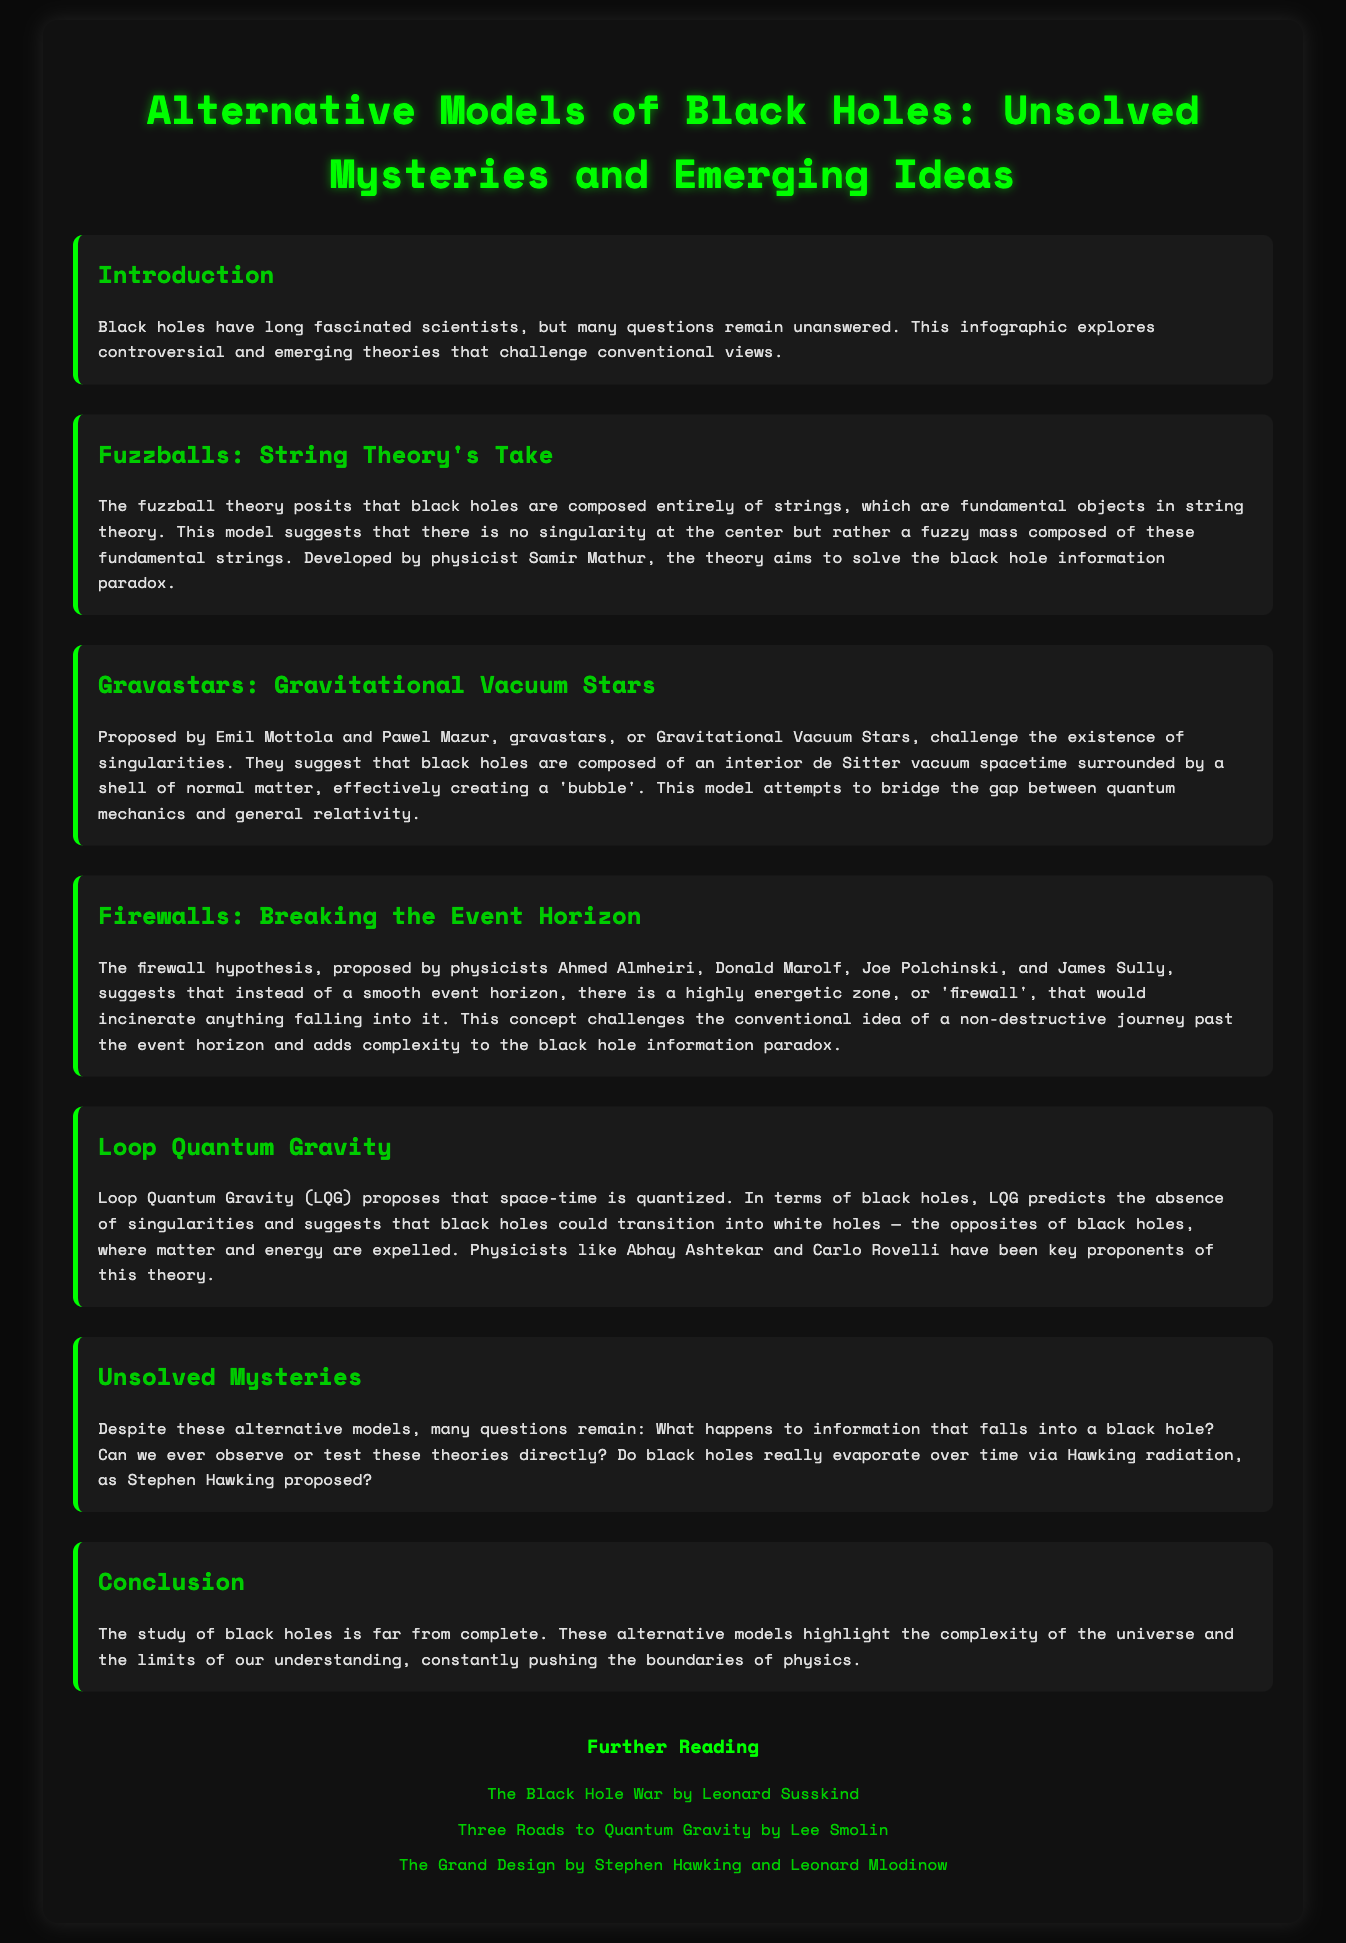What theory suggests black holes are made of strings? The document states that the fuzzball theory posits that black holes are composed entirely of strings.
Answer: Fuzzballs Who developed the fuzzball theory? The document mentions that the fuzzball theory was developed by physicist Samir Mathur.
Answer: Samir Mathur What do gravastars challenge? According to the document, gravastars challenge the existence of singularities.
Answer: Existence of singularities What phenomenon might black holes transition into according to Loop Quantum Gravity? The document describes that Loop Quantum Gravity suggests that black holes could transition into white holes.
Answer: White holes Which hypothesis proposes a highly energetic zone at the event horizon? The document indicates that the firewall hypothesis suggests a highly energetic zone, or 'firewall'.
Answer: Firewall hypothesis What is one of the unsolved mysteries regarding black holes mentioned? The document states a mystery about what happens to information that falls into a black hole.
Answer: Information falling into a black hole What is the purpose of this infographic? The document explains that the infographic explores controversial and emerging theories that challenge conventional views.
Answer: Explore controversial and emerging theories Who are some key proponents of Loop Quantum Gravity? The document lists physicists Abhay Ashtekar and Carlo Rovelli as key proponents of Loop Quantum Gravity.
Answer: Abhay Ashtekar and Carlo Rovelli What is the background color of the document? The document mentions that the background color is #0a0a0a.
Answer: #0a0a0a 